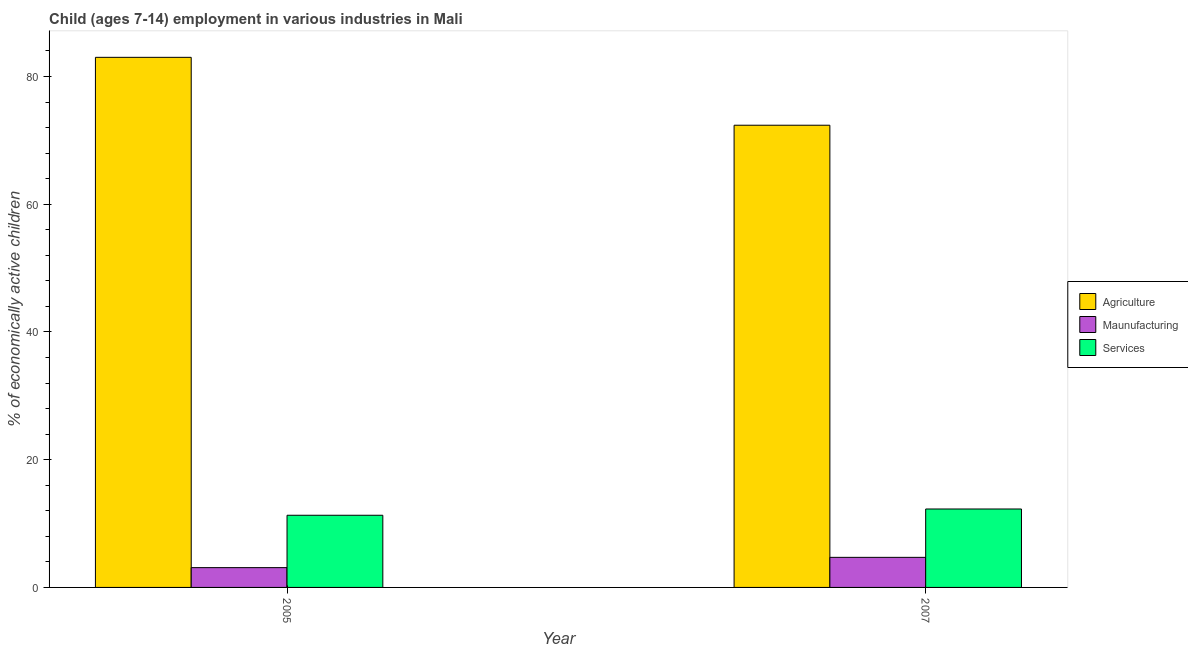How many different coloured bars are there?
Provide a succinct answer. 3. How many groups of bars are there?
Keep it short and to the point. 2. Are the number of bars per tick equal to the number of legend labels?
Your answer should be very brief. Yes. What is the label of the 1st group of bars from the left?
Make the answer very short. 2005. What is the percentage of economically active children in manufacturing in 2005?
Give a very brief answer. 3.1. Across all years, what is the maximum percentage of economically active children in services?
Provide a succinct answer. 12.28. In which year was the percentage of economically active children in services maximum?
Your answer should be very brief. 2007. In which year was the percentage of economically active children in services minimum?
Your answer should be very brief. 2005. What is the total percentage of economically active children in services in the graph?
Offer a very short reply. 23.58. What is the difference between the percentage of economically active children in manufacturing in 2005 and that in 2007?
Give a very brief answer. -1.61. What is the difference between the percentage of economically active children in services in 2007 and the percentage of economically active children in manufacturing in 2005?
Offer a very short reply. 0.98. What is the average percentage of economically active children in services per year?
Your answer should be very brief. 11.79. In the year 2007, what is the difference between the percentage of economically active children in services and percentage of economically active children in agriculture?
Keep it short and to the point. 0. In how many years, is the percentage of economically active children in manufacturing greater than 24 %?
Offer a very short reply. 0. What is the ratio of the percentage of economically active children in agriculture in 2005 to that in 2007?
Your response must be concise. 1.15. Is the percentage of economically active children in services in 2005 less than that in 2007?
Your answer should be compact. Yes. In how many years, is the percentage of economically active children in agriculture greater than the average percentage of economically active children in agriculture taken over all years?
Provide a short and direct response. 1. What does the 2nd bar from the left in 2007 represents?
Give a very brief answer. Maunufacturing. What does the 1st bar from the right in 2005 represents?
Your response must be concise. Services. Is it the case that in every year, the sum of the percentage of economically active children in agriculture and percentage of economically active children in manufacturing is greater than the percentage of economically active children in services?
Make the answer very short. Yes. How many bars are there?
Offer a terse response. 6. What is the difference between two consecutive major ticks on the Y-axis?
Offer a very short reply. 20. Does the graph contain grids?
Make the answer very short. No. How many legend labels are there?
Give a very brief answer. 3. What is the title of the graph?
Offer a terse response. Child (ages 7-14) employment in various industries in Mali. What is the label or title of the X-axis?
Offer a terse response. Year. What is the label or title of the Y-axis?
Give a very brief answer. % of economically active children. What is the % of economically active children in Agriculture in 2007?
Ensure brevity in your answer.  72.37. What is the % of economically active children in Maunufacturing in 2007?
Provide a succinct answer. 4.71. What is the % of economically active children of Services in 2007?
Make the answer very short. 12.28. Across all years, what is the maximum % of economically active children of Agriculture?
Your response must be concise. 83. Across all years, what is the maximum % of economically active children in Maunufacturing?
Ensure brevity in your answer.  4.71. Across all years, what is the maximum % of economically active children of Services?
Provide a short and direct response. 12.28. Across all years, what is the minimum % of economically active children of Agriculture?
Offer a very short reply. 72.37. What is the total % of economically active children of Agriculture in the graph?
Your response must be concise. 155.37. What is the total % of economically active children of Maunufacturing in the graph?
Your answer should be compact. 7.81. What is the total % of economically active children in Services in the graph?
Make the answer very short. 23.58. What is the difference between the % of economically active children in Agriculture in 2005 and that in 2007?
Offer a very short reply. 10.63. What is the difference between the % of economically active children in Maunufacturing in 2005 and that in 2007?
Keep it short and to the point. -1.61. What is the difference between the % of economically active children in Services in 2005 and that in 2007?
Provide a short and direct response. -0.98. What is the difference between the % of economically active children of Agriculture in 2005 and the % of economically active children of Maunufacturing in 2007?
Give a very brief answer. 78.29. What is the difference between the % of economically active children in Agriculture in 2005 and the % of economically active children in Services in 2007?
Keep it short and to the point. 70.72. What is the difference between the % of economically active children in Maunufacturing in 2005 and the % of economically active children in Services in 2007?
Keep it short and to the point. -9.18. What is the average % of economically active children in Agriculture per year?
Make the answer very short. 77.69. What is the average % of economically active children in Maunufacturing per year?
Your response must be concise. 3.9. What is the average % of economically active children of Services per year?
Offer a terse response. 11.79. In the year 2005, what is the difference between the % of economically active children of Agriculture and % of economically active children of Maunufacturing?
Keep it short and to the point. 79.9. In the year 2005, what is the difference between the % of economically active children in Agriculture and % of economically active children in Services?
Your response must be concise. 71.7. In the year 2005, what is the difference between the % of economically active children in Maunufacturing and % of economically active children in Services?
Offer a terse response. -8.2. In the year 2007, what is the difference between the % of economically active children of Agriculture and % of economically active children of Maunufacturing?
Your answer should be very brief. 67.66. In the year 2007, what is the difference between the % of economically active children in Agriculture and % of economically active children in Services?
Offer a very short reply. 60.09. In the year 2007, what is the difference between the % of economically active children in Maunufacturing and % of economically active children in Services?
Your answer should be very brief. -7.57. What is the ratio of the % of economically active children in Agriculture in 2005 to that in 2007?
Your response must be concise. 1.15. What is the ratio of the % of economically active children in Maunufacturing in 2005 to that in 2007?
Your response must be concise. 0.66. What is the ratio of the % of economically active children in Services in 2005 to that in 2007?
Your answer should be very brief. 0.92. What is the difference between the highest and the second highest % of economically active children of Agriculture?
Give a very brief answer. 10.63. What is the difference between the highest and the second highest % of economically active children in Maunufacturing?
Keep it short and to the point. 1.61. What is the difference between the highest and the lowest % of economically active children in Agriculture?
Your answer should be compact. 10.63. What is the difference between the highest and the lowest % of economically active children in Maunufacturing?
Provide a short and direct response. 1.61. What is the difference between the highest and the lowest % of economically active children in Services?
Your answer should be very brief. 0.98. 